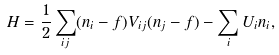<formula> <loc_0><loc_0><loc_500><loc_500>H = \frac { 1 } { 2 } \sum _ { i j } ( n _ { i } - f ) V _ { i j } ( n _ { j } - f ) - \sum _ { i } U _ { i } n _ { i } ,</formula> 